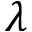<formula> <loc_0><loc_0><loc_500><loc_500>\lambda</formula> 